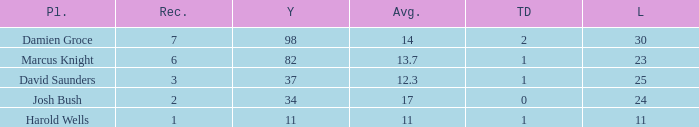How many TDs are there were the long is smaller than 23? 1.0. 